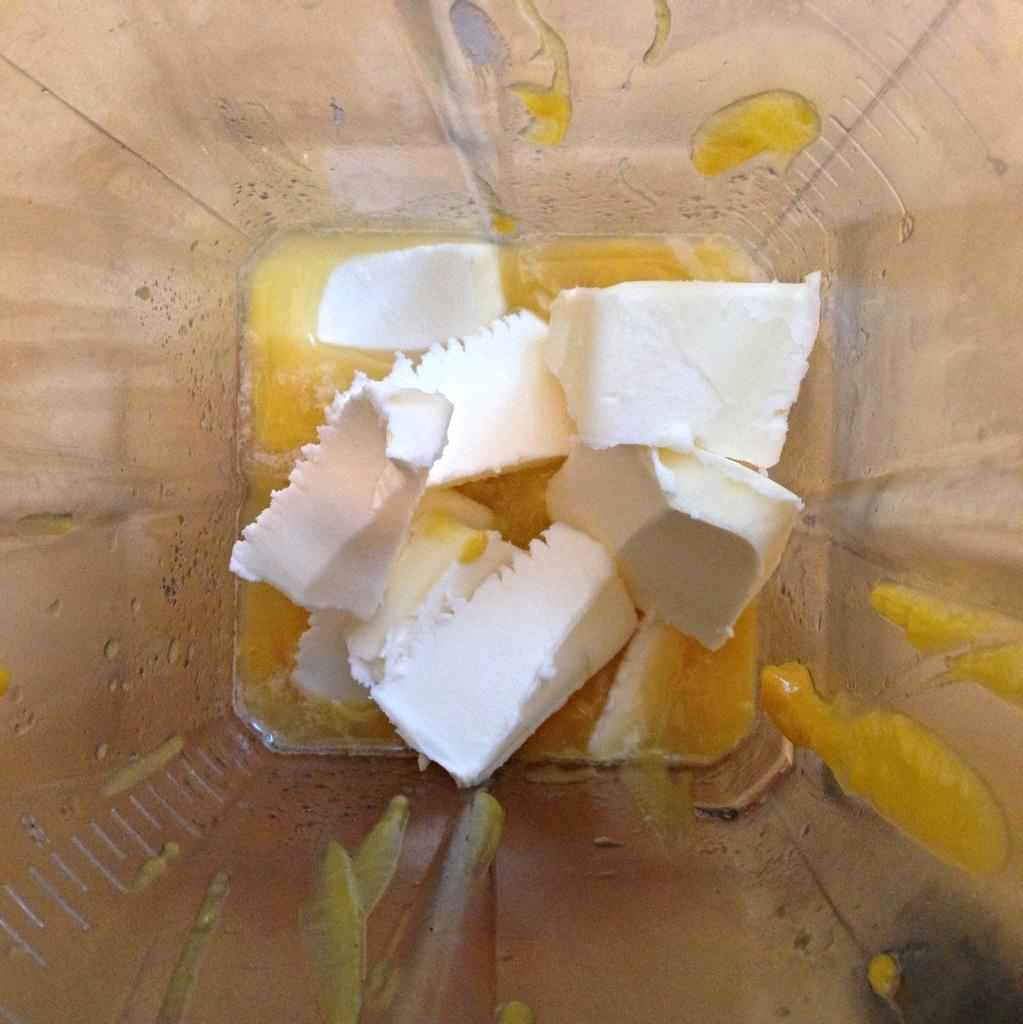What type of container is visible in the image? There is a plastic container in the image. What is inside the container? The container holds a yellow liquid and white objects. What color is the surface on which the container is placed? The container is placed on a cream-colored surface. What thrilling theory is being discussed in the image? There is no discussion or theory present in the image; it features a plastic container with a yellow liquid and white objects on a cream-colored surface. 